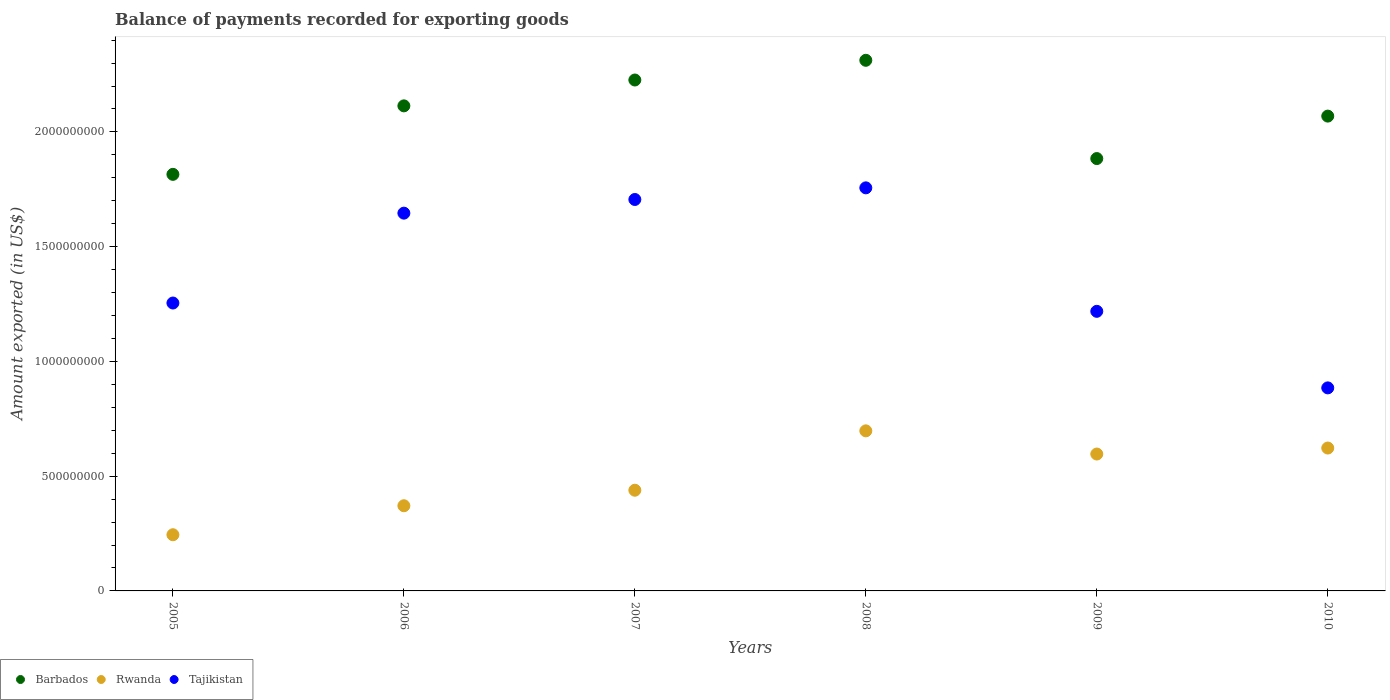How many different coloured dotlines are there?
Offer a terse response. 3. Is the number of dotlines equal to the number of legend labels?
Give a very brief answer. Yes. What is the amount exported in Rwanda in 2006?
Offer a terse response. 3.71e+08. Across all years, what is the maximum amount exported in Rwanda?
Offer a terse response. 6.97e+08. Across all years, what is the minimum amount exported in Barbados?
Provide a short and direct response. 1.82e+09. What is the total amount exported in Rwanda in the graph?
Keep it short and to the point. 2.97e+09. What is the difference between the amount exported in Rwanda in 2005 and that in 2009?
Keep it short and to the point. -3.52e+08. What is the difference between the amount exported in Rwanda in 2006 and the amount exported in Tajikistan in 2005?
Your answer should be very brief. -8.83e+08. What is the average amount exported in Tajikistan per year?
Offer a terse response. 1.41e+09. In the year 2009, what is the difference between the amount exported in Tajikistan and amount exported in Barbados?
Your response must be concise. -6.66e+08. In how many years, is the amount exported in Barbados greater than 100000000 US$?
Make the answer very short. 6. What is the ratio of the amount exported in Barbados in 2006 to that in 2010?
Your response must be concise. 1.02. Is the amount exported in Barbados in 2005 less than that in 2008?
Your response must be concise. Yes. Is the difference between the amount exported in Tajikistan in 2006 and 2010 greater than the difference between the amount exported in Barbados in 2006 and 2010?
Your response must be concise. Yes. What is the difference between the highest and the second highest amount exported in Tajikistan?
Give a very brief answer. 5.07e+07. What is the difference between the highest and the lowest amount exported in Tajikistan?
Give a very brief answer. 8.72e+08. In how many years, is the amount exported in Rwanda greater than the average amount exported in Rwanda taken over all years?
Ensure brevity in your answer.  3. Is it the case that in every year, the sum of the amount exported in Tajikistan and amount exported in Rwanda  is greater than the amount exported in Barbados?
Make the answer very short. No. Is the amount exported in Rwanda strictly greater than the amount exported in Barbados over the years?
Ensure brevity in your answer.  No. How many dotlines are there?
Your answer should be compact. 3. How many years are there in the graph?
Ensure brevity in your answer.  6. Does the graph contain any zero values?
Give a very brief answer. No. Where does the legend appear in the graph?
Offer a terse response. Bottom left. What is the title of the graph?
Keep it short and to the point. Balance of payments recorded for exporting goods. Does "Germany" appear as one of the legend labels in the graph?
Offer a terse response. No. What is the label or title of the Y-axis?
Ensure brevity in your answer.  Amount exported (in US$). What is the Amount exported (in US$) of Barbados in 2005?
Offer a very short reply. 1.82e+09. What is the Amount exported (in US$) of Rwanda in 2005?
Your answer should be compact. 2.45e+08. What is the Amount exported (in US$) of Tajikistan in 2005?
Your answer should be very brief. 1.25e+09. What is the Amount exported (in US$) of Barbados in 2006?
Offer a very short reply. 2.11e+09. What is the Amount exported (in US$) in Rwanda in 2006?
Your answer should be very brief. 3.71e+08. What is the Amount exported (in US$) in Tajikistan in 2006?
Keep it short and to the point. 1.65e+09. What is the Amount exported (in US$) of Barbados in 2007?
Your answer should be very brief. 2.23e+09. What is the Amount exported (in US$) of Rwanda in 2007?
Make the answer very short. 4.39e+08. What is the Amount exported (in US$) of Tajikistan in 2007?
Offer a terse response. 1.71e+09. What is the Amount exported (in US$) of Barbados in 2008?
Provide a short and direct response. 2.31e+09. What is the Amount exported (in US$) in Rwanda in 2008?
Make the answer very short. 6.97e+08. What is the Amount exported (in US$) in Tajikistan in 2008?
Keep it short and to the point. 1.76e+09. What is the Amount exported (in US$) of Barbados in 2009?
Provide a short and direct response. 1.88e+09. What is the Amount exported (in US$) of Rwanda in 2009?
Make the answer very short. 5.96e+08. What is the Amount exported (in US$) in Tajikistan in 2009?
Make the answer very short. 1.22e+09. What is the Amount exported (in US$) of Barbados in 2010?
Keep it short and to the point. 2.07e+09. What is the Amount exported (in US$) of Rwanda in 2010?
Your answer should be very brief. 6.23e+08. What is the Amount exported (in US$) in Tajikistan in 2010?
Offer a terse response. 8.85e+08. Across all years, what is the maximum Amount exported (in US$) of Barbados?
Provide a succinct answer. 2.31e+09. Across all years, what is the maximum Amount exported (in US$) in Rwanda?
Your answer should be very brief. 6.97e+08. Across all years, what is the maximum Amount exported (in US$) in Tajikistan?
Give a very brief answer. 1.76e+09. Across all years, what is the minimum Amount exported (in US$) of Barbados?
Provide a short and direct response. 1.82e+09. Across all years, what is the minimum Amount exported (in US$) of Rwanda?
Give a very brief answer. 2.45e+08. Across all years, what is the minimum Amount exported (in US$) in Tajikistan?
Your answer should be compact. 8.85e+08. What is the total Amount exported (in US$) of Barbados in the graph?
Your response must be concise. 1.24e+1. What is the total Amount exported (in US$) in Rwanda in the graph?
Ensure brevity in your answer.  2.97e+09. What is the total Amount exported (in US$) in Tajikistan in the graph?
Keep it short and to the point. 8.47e+09. What is the difference between the Amount exported (in US$) of Barbados in 2005 and that in 2006?
Your answer should be very brief. -2.98e+08. What is the difference between the Amount exported (in US$) of Rwanda in 2005 and that in 2006?
Keep it short and to the point. -1.26e+08. What is the difference between the Amount exported (in US$) in Tajikistan in 2005 and that in 2006?
Make the answer very short. -3.92e+08. What is the difference between the Amount exported (in US$) of Barbados in 2005 and that in 2007?
Give a very brief answer. -4.11e+08. What is the difference between the Amount exported (in US$) of Rwanda in 2005 and that in 2007?
Make the answer very short. -1.94e+08. What is the difference between the Amount exported (in US$) of Tajikistan in 2005 and that in 2007?
Your response must be concise. -4.51e+08. What is the difference between the Amount exported (in US$) of Barbados in 2005 and that in 2008?
Your response must be concise. -4.97e+08. What is the difference between the Amount exported (in US$) in Rwanda in 2005 and that in 2008?
Provide a succinct answer. -4.53e+08. What is the difference between the Amount exported (in US$) in Tajikistan in 2005 and that in 2008?
Your answer should be very brief. -5.02e+08. What is the difference between the Amount exported (in US$) in Barbados in 2005 and that in 2009?
Offer a terse response. -6.88e+07. What is the difference between the Amount exported (in US$) of Rwanda in 2005 and that in 2009?
Provide a succinct answer. -3.52e+08. What is the difference between the Amount exported (in US$) in Tajikistan in 2005 and that in 2009?
Your answer should be compact. 3.62e+07. What is the difference between the Amount exported (in US$) of Barbados in 2005 and that in 2010?
Offer a very short reply. -2.54e+08. What is the difference between the Amount exported (in US$) in Rwanda in 2005 and that in 2010?
Keep it short and to the point. -3.78e+08. What is the difference between the Amount exported (in US$) of Tajikistan in 2005 and that in 2010?
Your answer should be compact. 3.70e+08. What is the difference between the Amount exported (in US$) of Barbados in 2006 and that in 2007?
Make the answer very short. -1.13e+08. What is the difference between the Amount exported (in US$) in Rwanda in 2006 and that in 2007?
Provide a short and direct response. -6.76e+07. What is the difference between the Amount exported (in US$) of Tajikistan in 2006 and that in 2007?
Make the answer very short. -5.96e+07. What is the difference between the Amount exported (in US$) in Barbados in 2006 and that in 2008?
Give a very brief answer. -1.99e+08. What is the difference between the Amount exported (in US$) of Rwanda in 2006 and that in 2008?
Give a very brief answer. -3.26e+08. What is the difference between the Amount exported (in US$) in Tajikistan in 2006 and that in 2008?
Your response must be concise. -1.10e+08. What is the difference between the Amount exported (in US$) in Barbados in 2006 and that in 2009?
Your response must be concise. 2.30e+08. What is the difference between the Amount exported (in US$) in Rwanda in 2006 and that in 2009?
Ensure brevity in your answer.  -2.25e+08. What is the difference between the Amount exported (in US$) in Tajikistan in 2006 and that in 2009?
Keep it short and to the point. 4.28e+08. What is the difference between the Amount exported (in US$) in Barbados in 2006 and that in 2010?
Make the answer very short. 4.46e+07. What is the difference between the Amount exported (in US$) in Rwanda in 2006 and that in 2010?
Provide a short and direct response. -2.51e+08. What is the difference between the Amount exported (in US$) of Tajikistan in 2006 and that in 2010?
Your response must be concise. 7.61e+08. What is the difference between the Amount exported (in US$) in Barbados in 2007 and that in 2008?
Make the answer very short. -8.59e+07. What is the difference between the Amount exported (in US$) in Rwanda in 2007 and that in 2008?
Provide a succinct answer. -2.59e+08. What is the difference between the Amount exported (in US$) of Tajikistan in 2007 and that in 2008?
Make the answer very short. -5.07e+07. What is the difference between the Amount exported (in US$) of Barbados in 2007 and that in 2009?
Ensure brevity in your answer.  3.42e+08. What is the difference between the Amount exported (in US$) in Rwanda in 2007 and that in 2009?
Offer a very short reply. -1.58e+08. What is the difference between the Amount exported (in US$) in Tajikistan in 2007 and that in 2009?
Provide a succinct answer. 4.87e+08. What is the difference between the Amount exported (in US$) in Barbados in 2007 and that in 2010?
Your response must be concise. 1.57e+08. What is the difference between the Amount exported (in US$) in Rwanda in 2007 and that in 2010?
Your answer should be very brief. -1.84e+08. What is the difference between the Amount exported (in US$) in Tajikistan in 2007 and that in 2010?
Offer a terse response. 8.21e+08. What is the difference between the Amount exported (in US$) in Barbados in 2008 and that in 2009?
Your response must be concise. 4.28e+08. What is the difference between the Amount exported (in US$) of Rwanda in 2008 and that in 2009?
Make the answer very short. 1.01e+08. What is the difference between the Amount exported (in US$) in Tajikistan in 2008 and that in 2009?
Keep it short and to the point. 5.38e+08. What is the difference between the Amount exported (in US$) of Barbados in 2008 and that in 2010?
Provide a short and direct response. 2.43e+08. What is the difference between the Amount exported (in US$) in Rwanda in 2008 and that in 2010?
Ensure brevity in your answer.  7.49e+07. What is the difference between the Amount exported (in US$) of Tajikistan in 2008 and that in 2010?
Keep it short and to the point. 8.72e+08. What is the difference between the Amount exported (in US$) in Barbados in 2009 and that in 2010?
Make the answer very short. -1.85e+08. What is the difference between the Amount exported (in US$) of Rwanda in 2009 and that in 2010?
Keep it short and to the point. -2.61e+07. What is the difference between the Amount exported (in US$) in Tajikistan in 2009 and that in 2010?
Provide a short and direct response. 3.34e+08. What is the difference between the Amount exported (in US$) of Barbados in 2005 and the Amount exported (in US$) of Rwanda in 2006?
Your answer should be compact. 1.44e+09. What is the difference between the Amount exported (in US$) in Barbados in 2005 and the Amount exported (in US$) in Tajikistan in 2006?
Keep it short and to the point. 1.69e+08. What is the difference between the Amount exported (in US$) of Rwanda in 2005 and the Amount exported (in US$) of Tajikistan in 2006?
Ensure brevity in your answer.  -1.40e+09. What is the difference between the Amount exported (in US$) in Barbados in 2005 and the Amount exported (in US$) in Rwanda in 2007?
Give a very brief answer. 1.38e+09. What is the difference between the Amount exported (in US$) in Barbados in 2005 and the Amount exported (in US$) in Tajikistan in 2007?
Provide a succinct answer. 1.09e+08. What is the difference between the Amount exported (in US$) in Rwanda in 2005 and the Amount exported (in US$) in Tajikistan in 2007?
Offer a terse response. -1.46e+09. What is the difference between the Amount exported (in US$) of Barbados in 2005 and the Amount exported (in US$) of Rwanda in 2008?
Your response must be concise. 1.12e+09. What is the difference between the Amount exported (in US$) in Barbados in 2005 and the Amount exported (in US$) in Tajikistan in 2008?
Offer a terse response. 5.88e+07. What is the difference between the Amount exported (in US$) in Rwanda in 2005 and the Amount exported (in US$) in Tajikistan in 2008?
Provide a short and direct response. -1.51e+09. What is the difference between the Amount exported (in US$) of Barbados in 2005 and the Amount exported (in US$) of Rwanda in 2009?
Provide a short and direct response. 1.22e+09. What is the difference between the Amount exported (in US$) in Barbados in 2005 and the Amount exported (in US$) in Tajikistan in 2009?
Your response must be concise. 5.97e+08. What is the difference between the Amount exported (in US$) in Rwanda in 2005 and the Amount exported (in US$) in Tajikistan in 2009?
Your answer should be compact. -9.73e+08. What is the difference between the Amount exported (in US$) of Barbados in 2005 and the Amount exported (in US$) of Rwanda in 2010?
Offer a terse response. 1.19e+09. What is the difference between the Amount exported (in US$) of Barbados in 2005 and the Amount exported (in US$) of Tajikistan in 2010?
Your answer should be compact. 9.30e+08. What is the difference between the Amount exported (in US$) of Rwanda in 2005 and the Amount exported (in US$) of Tajikistan in 2010?
Provide a succinct answer. -6.40e+08. What is the difference between the Amount exported (in US$) in Barbados in 2006 and the Amount exported (in US$) in Rwanda in 2007?
Ensure brevity in your answer.  1.67e+09. What is the difference between the Amount exported (in US$) in Barbados in 2006 and the Amount exported (in US$) in Tajikistan in 2007?
Ensure brevity in your answer.  4.08e+08. What is the difference between the Amount exported (in US$) of Rwanda in 2006 and the Amount exported (in US$) of Tajikistan in 2007?
Give a very brief answer. -1.33e+09. What is the difference between the Amount exported (in US$) of Barbados in 2006 and the Amount exported (in US$) of Rwanda in 2008?
Make the answer very short. 1.42e+09. What is the difference between the Amount exported (in US$) in Barbados in 2006 and the Amount exported (in US$) in Tajikistan in 2008?
Give a very brief answer. 3.57e+08. What is the difference between the Amount exported (in US$) in Rwanda in 2006 and the Amount exported (in US$) in Tajikistan in 2008?
Offer a terse response. -1.39e+09. What is the difference between the Amount exported (in US$) in Barbados in 2006 and the Amount exported (in US$) in Rwanda in 2009?
Provide a succinct answer. 1.52e+09. What is the difference between the Amount exported (in US$) in Barbados in 2006 and the Amount exported (in US$) in Tajikistan in 2009?
Your answer should be very brief. 8.95e+08. What is the difference between the Amount exported (in US$) of Rwanda in 2006 and the Amount exported (in US$) of Tajikistan in 2009?
Provide a short and direct response. -8.47e+08. What is the difference between the Amount exported (in US$) of Barbados in 2006 and the Amount exported (in US$) of Rwanda in 2010?
Offer a terse response. 1.49e+09. What is the difference between the Amount exported (in US$) in Barbados in 2006 and the Amount exported (in US$) in Tajikistan in 2010?
Ensure brevity in your answer.  1.23e+09. What is the difference between the Amount exported (in US$) in Rwanda in 2006 and the Amount exported (in US$) in Tajikistan in 2010?
Your response must be concise. -5.14e+08. What is the difference between the Amount exported (in US$) of Barbados in 2007 and the Amount exported (in US$) of Rwanda in 2008?
Your answer should be very brief. 1.53e+09. What is the difference between the Amount exported (in US$) of Barbados in 2007 and the Amount exported (in US$) of Tajikistan in 2008?
Make the answer very short. 4.70e+08. What is the difference between the Amount exported (in US$) of Rwanda in 2007 and the Amount exported (in US$) of Tajikistan in 2008?
Offer a very short reply. -1.32e+09. What is the difference between the Amount exported (in US$) in Barbados in 2007 and the Amount exported (in US$) in Rwanda in 2009?
Your response must be concise. 1.63e+09. What is the difference between the Amount exported (in US$) of Barbados in 2007 and the Amount exported (in US$) of Tajikistan in 2009?
Your response must be concise. 1.01e+09. What is the difference between the Amount exported (in US$) of Rwanda in 2007 and the Amount exported (in US$) of Tajikistan in 2009?
Make the answer very short. -7.79e+08. What is the difference between the Amount exported (in US$) of Barbados in 2007 and the Amount exported (in US$) of Rwanda in 2010?
Your answer should be very brief. 1.60e+09. What is the difference between the Amount exported (in US$) of Barbados in 2007 and the Amount exported (in US$) of Tajikistan in 2010?
Keep it short and to the point. 1.34e+09. What is the difference between the Amount exported (in US$) in Rwanda in 2007 and the Amount exported (in US$) in Tajikistan in 2010?
Your answer should be compact. -4.46e+08. What is the difference between the Amount exported (in US$) in Barbados in 2008 and the Amount exported (in US$) in Rwanda in 2009?
Your answer should be compact. 1.72e+09. What is the difference between the Amount exported (in US$) in Barbados in 2008 and the Amount exported (in US$) in Tajikistan in 2009?
Provide a short and direct response. 1.09e+09. What is the difference between the Amount exported (in US$) of Rwanda in 2008 and the Amount exported (in US$) of Tajikistan in 2009?
Provide a short and direct response. -5.21e+08. What is the difference between the Amount exported (in US$) of Barbados in 2008 and the Amount exported (in US$) of Rwanda in 2010?
Your answer should be very brief. 1.69e+09. What is the difference between the Amount exported (in US$) of Barbados in 2008 and the Amount exported (in US$) of Tajikistan in 2010?
Provide a succinct answer. 1.43e+09. What is the difference between the Amount exported (in US$) in Rwanda in 2008 and the Amount exported (in US$) in Tajikistan in 2010?
Your answer should be very brief. -1.87e+08. What is the difference between the Amount exported (in US$) in Barbados in 2009 and the Amount exported (in US$) in Rwanda in 2010?
Provide a succinct answer. 1.26e+09. What is the difference between the Amount exported (in US$) in Barbados in 2009 and the Amount exported (in US$) in Tajikistan in 2010?
Provide a succinct answer. 9.99e+08. What is the difference between the Amount exported (in US$) in Rwanda in 2009 and the Amount exported (in US$) in Tajikistan in 2010?
Offer a very short reply. -2.88e+08. What is the average Amount exported (in US$) of Barbados per year?
Offer a very short reply. 2.07e+09. What is the average Amount exported (in US$) in Rwanda per year?
Give a very brief answer. 4.95e+08. What is the average Amount exported (in US$) in Tajikistan per year?
Offer a very short reply. 1.41e+09. In the year 2005, what is the difference between the Amount exported (in US$) of Barbados and Amount exported (in US$) of Rwanda?
Provide a succinct answer. 1.57e+09. In the year 2005, what is the difference between the Amount exported (in US$) in Barbados and Amount exported (in US$) in Tajikistan?
Offer a terse response. 5.61e+08. In the year 2005, what is the difference between the Amount exported (in US$) in Rwanda and Amount exported (in US$) in Tajikistan?
Make the answer very short. -1.01e+09. In the year 2006, what is the difference between the Amount exported (in US$) in Barbados and Amount exported (in US$) in Rwanda?
Keep it short and to the point. 1.74e+09. In the year 2006, what is the difference between the Amount exported (in US$) of Barbados and Amount exported (in US$) of Tajikistan?
Offer a very short reply. 4.67e+08. In the year 2006, what is the difference between the Amount exported (in US$) in Rwanda and Amount exported (in US$) in Tajikistan?
Provide a short and direct response. -1.27e+09. In the year 2007, what is the difference between the Amount exported (in US$) in Barbados and Amount exported (in US$) in Rwanda?
Provide a short and direct response. 1.79e+09. In the year 2007, what is the difference between the Amount exported (in US$) in Barbados and Amount exported (in US$) in Tajikistan?
Offer a terse response. 5.21e+08. In the year 2007, what is the difference between the Amount exported (in US$) of Rwanda and Amount exported (in US$) of Tajikistan?
Your response must be concise. -1.27e+09. In the year 2008, what is the difference between the Amount exported (in US$) in Barbados and Amount exported (in US$) in Rwanda?
Give a very brief answer. 1.61e+09. In the year 2008, what is the difference between the Amount exported (in US$) of Barbados and Amount exported (in US$) of Tajikistan?
Provide a short and direct response. 5.56e+08. In the year 2008, what is the difference between the Amount exported (in US$) of Rwanda and Amount exported (in US$) of Tajikistan?
Your answer should be compact. -1.06e+09. In the year 2009, what is the difference between the Amount exported (in US$) of Barbados and Amount exported (in US$) of Rwanda?
Offer a very short reply. 1.29e+09. In the year 2009, what is the difference between the Amount exported (in US$) in Barbados and Amount exported (in US$) in Tajikistan?
Offer a very short reply. 6.66e+08. In the year 2009, what is the difference between the Amount exported (in US$) in Rwanda and Amount exported (in US$) in Tajikistan?
Make the answer very short. -6.22e+08. In the year 2010, what is the difference between the Amount exported (in US$) of Barbados and Amount exported (in US$) of Rwanda?
Provide a succinct answer. 1.45e+09. In the year 2010, what is the difference between the Amount exported (in US$) in Barbados and Amount exported (in US$) in Tajikistan?
Make the answer very short. 1.18e+09. In the year 2010, what is the difference between the Amount exported (in US$) in Rwanda and Amount exported (in US$) in Tajikistan?
Offer a terse response. -2.62e+08. What is the ratio of the Amount exported (in US$) in Barbados in 2005 to that in 2006?
Provide a succinct answer. 0.86. What is the ratio of the Amount exported (in US$) in Rwanda in 2005 to that in 2006?
Ensure brevity in your answer.  0.66. What is the ratio of the Amount exported (in US$) in Tajikistan in 2005 to that in 2006?
Make the answer very short. 0.76. What is the ratio of the Amount exported (in US$) in Barbados in 2005 to that in 2007?
Your answer should be compact. 0.82. What is the ratio of the Amount exported (in US$) in Rwanda in 2005 to that in 2007?
Keep it short and to the point. 0.56. What is the ratio of the Amount exported (in US$) of Tajikistan in 2005 to that in 2007?
Your answer should be compact. 0.74. What is the ratio of the Amount exported (in US$) of Barbados in 2005 to that in 2008?
Ensure brevity in your answer.  0.79. What is the ratio of the Amount exported (in US$) in Rwanda in 2005 to that in 2008?
Keep it short and to the point. 0.35. What is the ratio of the Amount exported (in US$) of Barbados in 2005 to that in 2009?
Your response must be concise. 0.96. What is the ratio of the Amount exported (in US$) in Rwanda in 2005 to that in 2009?
Offer a terse response. 0.41. What is the ratio of the Amount exported (in US$) of Tajikistan in 2005 to that in 2009?
Give a very brief answer. 1.03. What is the ratio of the Amount exported (in US$) of Barbados in 2005 to that in 2010?
Give a very brief answer. 0.88. What is the ratio of the Amount exported (in US$) of Rwanda in 2005 to that in 2010?
Your answer should be compact. 0.39. What is the ratio of the Amount exported (in US$) of Tajikistan in 2005 to that in 2010?
Your answer should be compact. 1.42. What is the ratio of the Amount exported (in US$) of Barbados in 2006 to that in 2007?
Your response must be concise. 0.95. What is the ratio of the Amount exported (in US$) of Rwanda in 2006 to that in 2007?
Provide a succinct answer. 0.85. What is the ratio of the Amount exported (in US$) of Tajikistan in 2006 to that in 2007?
Your response must be concise. 0.97. What is the ratio of the Amount exported (in US$) of Barbados in 2006 to that in 2008?
Keep it short and to the point. 0.91. What is the ratio of the Amount exported (in US$) in Rwanda in 2006 to that in 2008?
Keep it short and to the point. 0.53. What is the ratio of the Amount exported (in US$) in Tajikistan in 2006 to that in 2008?
Keep it short and to the point. 0.94. What is the ratio of the Amount exported (in US$) in Barbados in 2006 to that in 2009?
Make the answer very short. 1.12. What is the ratio of the Amount exported (in US$) of Rwanda in 2006 to that in 2009?
Ensure brevity in your answer.  0.62. What is the ratio of the Amount exported (in US$) in Tajikistan in 2006 to that in 2009?
Offer a very short reply. 1.35. What is the ratio of the Amount exported (in US$) in Barbados in 2006 to that in 2010?
Give a very brief answer. 1.02. What is the ratio of the Amount exported (in US$) in Rwanda in 2006 to that in 2010?
Your response must be concise. 0.6. What is the ratio of the Amount exported (in US$) in Tajikistan in 2006 to that in 2010?
Provide a succinct answer. 1.86. What is the ratio of the Amount exported (in US$) of Barbados in 2007 to that in 2008?
Provide a succinct answer. 0.96. What is the ratio of the Amount exported (in US$) of Rwanda in 2007 to that in 2008?
Make the answer very short. 0.63. What is the ratio of the Amount exported (in US$) in Tajikistan in 2007 to that in 2008?
Your response must be concise. 0.97. What is the ratio of the Amount exported (in US$) of Barbados in 2007 to that in 2009?
Provide a succinct answer. 1.18. What is the ratio of the Amount exported (in US$) in Rwanda in 2007 to that in 2009?
Provide a succinct answer. 0.74. What is the ratio of the Amount exported (in US$) of Barbados in 2007 to that in 2010?
Your response must be concise. 1.08. What is the ratio of the Amount exported (in US$) of Rwanda in 2007 to that in 2010?
Offer a terse response. 0.7. What is the ratio of the Amount exported (in US$) in Tajikistan in 2007 to that in 2010?
Your answer should be very brief. 1.93. What is the ratio of the Amount exported (in US$) of Barbados in 2008 to that in 2009?
Your response must be concise. 1.23. What is the ratio of the Amount exported (in US$) in Rwanda in 2008 to that in 2009?
Offer a very short reply. 1.17. What is the ratio of the Amount exported (in US$) in Tajikistan in 2008 to that in 2009?
Provide a short and direct response. 1.44. What is the ratio of the Amount exported (in US$) in Barbados in 2008 to that in 2010?
Offer a very short reply. 1.12. What is the ratio of the Amount exported (in US$) in Rwanda in 2008 to that in 2010?
Your answer should be compact. 1.12. What is the ratio of the Amount exported (in US$) of Tajikistan in 2008 to that in 2010?
Offer a terse response. 1.99. What is the ratio of the Amount exported (in US$) of Barbados in 2009 to that in 2010?
Give a very brief answer. 0.91. What is the ratio of the Amount exported (in US$) in Rwanda in 2009 to that in 2010?
Your answer should be compact. 0.96. What is the ratio of the Amount exported (in US$) in Tajikistan in 2009 to that in 2010?
Offer a very short reply. 1.38. What is the difference between the highest and the second highest Amount exported (in US$) in Barbados?
Ensure brevity in your answer.  8.59e+07. What is the difference between the highest and the second highest Amount exported (in US$) in Rwanda?
Provide a short and direct response. 7.49e+07. What is the difference between the highest and the second highest Amount exported (in US$) in Tajikistan?
Your answer should be compact. 5.07e+07. What is the difference between the highest and the lowest Amount exported (in US$) of Barbados?
Keep it short and to the point. 4.97e+08. What is the difference between the highest and the lowest Amount exported (in US$) in Rwanda?
Offer a terse response. 4.53e+08. What is the difference between the highest and the lowest Amount exported (in US$) in Tajikistan?
Your response must be concise. 8.72e+08. 